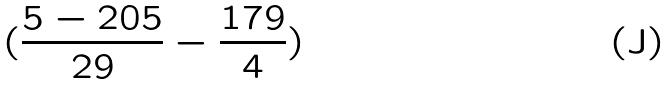Convert formula to latex. <formula><loc_0><loc_0><loc_500><loc_500>( \frac { 5 - 2 0 5 } { 2 9 } - \frac { 1 7 9 } { 4 } )</formula> 